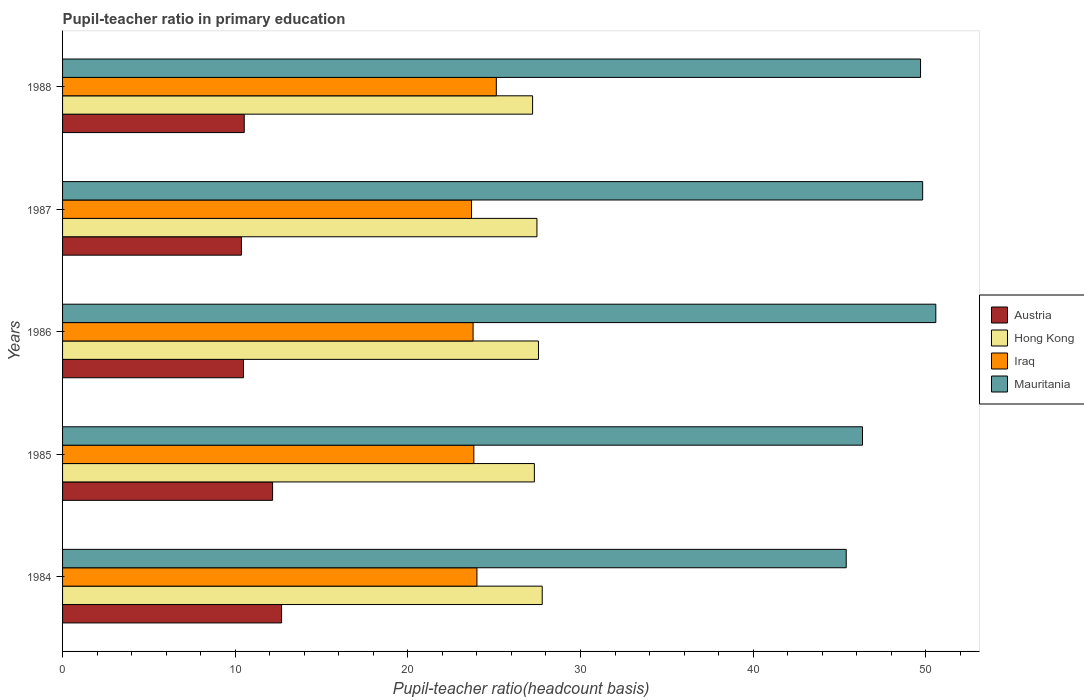In how many cases, is the number of bars for a given year not equal to the number of legend labels?
Offer a very short reply. 0. What is the pupil-teacher ratio in primary education in Iraq in 1987?
Keep it short and to the point. 23.69. Across all years, what is the maximum pupil-teacher ratio in primary education in Mauritania?
Offer a very short reply. 50.58. Across all years, what is the minimum pupil-teacher ratio in primary education in Austria?
Your answer should be very brief. 10.36. In which year was the pupil-teacher ratio in primary education in Mauritania maximum?
Offer a very short reply. 1986. What is the total pupil-teacher ratio in primary education in Hong Kong in the graph?
Give a very brief answer. 137.38. What is the difference between the pupil-teacher ratio in primary education in Iraq in 1985 and that in 1988?
Your answer should be compact. -1.3. What is the difference between the pupil-teacher ratio in primary education in Iraq in 1984 and the pupil-teacher ratio in primary education in Austria in 1986?
Your answer should be compact. 13.52. What is the average pupil-teacher ratio in primary education in Hong Kong per year?
Your response must be concise. 27.48. In the year 1984, what is the difference between the pupil-teacher ratio in primary education in Mauritania and pupil-teacher ratio in primary education in Iraq?
Your response must be concise. 21.39. In how many years, is the pupil-teacher ratio in primary education in Iraq greater than 8 ?
Your answer should be compact. 5. What is the ratio of the pupil-teacher ratio in primary education in Mauritania in 1984 to that in 1988?
Your response must be concise. 0.91. What is the difference between the highest and the second highest pupil-teacher ratio in primary education in Mauritania?
Your answer should be compact. 0.76. What is the difference between the highest and the lowest pupil-teacher ratio in primary education in Iraq?
Your answer should be compact. 1.44. Is the sum of the pupil-teacher ratio in primary education in Iraq in 1984 and 1985 greater than the maximum pupil-teacher ratio in primary education in Mauritania across all years?
Give a very brief answer. No. What does the 1st bar from the top in 1988 represents?
Keep it short and to the point. Mauritania. What does the 3rd bar from the bottom in 1988 represents?
Make the answer very short. Iraq. How many years are there in the graph?
Your answer should be compact. 5. Are the values on the major ticks of X-axis written in scientific E-notation?
Offer a very short reply. No. Does the graph contain grids?
Provide a succinct answer. No. How many legend labels are there?
Your answer should be compact. 4. What is the title of the graph?
Give a very brief answer. Pupil-teacher ratio in primary education. Does "South Africa" appear as one of the legend labels in the graph?
Make the answer very short. No. What is the label or title of the X-axis?
Ensure brevity in your answer.  Pupil-teacher ratio(headcount basis). What is the label or title of the Y-axis?
Provide a short and direct response. Years. What is the Pupil-teacher ratio(headcount basis) in Austria in 1984?
Your response must be concise. 12.69. What is the Pupil-teacher ratio(headcount basis) in Hong Kong in 1984?
Provide a short and direct response. 27.78. What is the Pupil-teacher ratio(headcount basis) of Iraq in 1984?
Provide a short and direct response. 24. What is the Pupil-teacher ratio(headcount basis) in Mauritania in 1984?
Your answer should be compact. 45.39. What is the Pupil-teacher ratio(headcount basis) of Austria in 1985?
Your answer should be compact. 12.17. What is the Pupil-teacher ratio(headcount basis) in Hong Kong in 1985?
Provide a short and direct response. 27.33. What is the Pupil-teacher ratio(headcount basis) of Iraq in 1985?
Your answer should be compact. 23.82. What is the Pupil-teacher ratio(headcount basis) of Mauritania in 1985?
Your response must be concise. 46.34. What is the Pupil-teacher ratio(headcount basis) in Austria in 1986?
Your response must be concise. 10.48. What is the Pupil-teacher ratio(headcount basis) in Hong Kong in 1986?
Make the answer very short. 27.57. What is the Pupil-teacher ratio(headcount basis) in Iraq in 1986?
Provide a short and direct response. 23.78. What is the Pupil-teacher ratio(headcount basis) of Mauritania in 1986?
Make the answer very short. 50.58. What is the Pupil-teacher ratio(headcount basis) of Austria in 1987?
Provide a short and direct response. 10.36. What is the Pupil-teacher ratio(headcount basis) in Hong Kong in 1987?
Provide a succinct answer. 27.48. What is the Pupil-teacher ratio(headcount basis) in Iraq in 1987?
Provide a succinct answer. 23.69. What is the Pupil-teacher ratio(headcount basis) in Mauritania in 1987?
Your answer should be very brief. 49.82. What is the Pupil-teacher ratio(headcount basis) in Austria in 1988?
Give a very brief answer. 10.52. What is the Pupil-teacher ratio(headcount basis) in Hong Kong in 1988?
Provide a succinct answer. 27.23. What is the Pupil-teacher ratio(headcount basis) of Iraq in 1988?
Your answer should be very brief. 25.13. What is the Pupil-teacher ratio(headcount basis) of Mauritania in 1988?
Offer a terse response. 49.7. Across all years, what is the maximum Pupil-teacher ratio(headcount basis) in Austria?
Offer a very short reply. 12.69. Across all years, what is the maximum Pupil-teacher ratio(headcount basis) in Hong Kong?
Keep it short and to the point. 27.78. Across all years, what is the maximum Pupil-teacher ratio(headcount basis) of Iraq?
Give a very brief answer. 25.13. Across all years, what is the maximum Pupil-teacher ratio(headcount basis) in Mauritania?
Make the answer very short. 50.58. Across all years, what is the minimum Pupil-teacher ratio(headcount basis) of Austria?
Make the answer very short. 10.36. Across all years, what is the minimum Pupil-teacher ratio(headcount basis) of Hong Kong?
Make the answer very short. 27.23. Across all years, what is the minimum Pupil-teacher ratio(headcount basis) in Iraq?
Your answer should be very brief. 23.69. Across all years, what is the minimum Pupil-teacher ratio(headcount basis) in Mauritania?
Offer a terse response. 45.39. What is the total Pupil-teacher ratio(headcount basis) in Austria in the graph?
Provide a succinct answer. 56.22. What is the total Pupil-teacher ratio(headcount basis) of Hong Kong in the graph?
Offer a very short reply. 137.38. What is the total Pupil-teacher ratio(headcount basis) in Iraq in the graph?
Keep it short and to the point. 120.42. What is the total Pupil-teacher ratio(headcount basis) of Mauritania in the graph?
Your response must be concise. 241.83. What is the difference between the Pupil-teacher ratio(headcount basis) in Austria in 1984 and that in 1985?
Your answer should be compact. 0.52. What is the difference between the Pupil-teacher ratio(headcount basis) in Hong Kong in 1984 and that in 1985?
Keep it short and to the point. 0.45. What is the difference between the Pupil-teacher ratio(headcount basis) of Iraq in 1984 and that in 1985?
Make the answer very short. 0.18. What is the difference between the Pupil-teacher ratio(headcount basis) in Mauritania in 1984 and that in 1985?
Provide a short and direct response. -0.94. What is the difference between the Pupil-teacher ratio(headcount basis) in Austria in 1984 and that in 1986?
Offer a terse response. 2.21. What is the difference between the Pupil-teacher ratio(headcount basis) of Hong Kong in 1984 and that in 1986?
Offer a terse response. 0.22. What is the difference between the Pupil-teacher ratio(headcount basis) of Iraq in 1984 and that in 1986?
Give a very brief answer. 0.22. What is the difference between the Pupil-teacher ratio(headcount basis) of Mauritania in 1984 and that in 1986?
Make the answer very short. -5.19. What is the difference between the Pupil-teacher ratio(headcount basis) of Austria in 1984 and that in 1987?
Offer a terse response. 2.32. What is the difference between the Pupil-teacher ratio(headcount basis) of Hong Kong in 1984 and that in 1987?
Provide a short and direct response. 0.31. What is the difference between the Pupil-teacher ratio(headcount basis) in Iraq in 1984 and that in 1987?
Your response must be concise. 0.31. What is the difference between the Pupil-teacher ratio(headcount basis) of Mauritania in 1984 and that in 1987?
Make the answer very short. -4.43. What is the difference between the Pupil-teacher ratio(headcount basis) of Austria in 1984 and that in 1988?
Make the answer very short. 2.16. What is the difference between the Pupil-teacher ratio(headcount basis) in Hong Kong in 1984 and that in 1988?
Provide a succinct answer. 0.56. What is the difference between the Pupil-teacher ratio(headcount basis) in Iraq in 1984 and that in 1988?
Provide a short and direct response. -1.12. What is the difference between the Pupil-teacher ratio(headcount basis) of Mauritania in 1984 and that in 1988?
Provide a succinct answer. -4.3. What is the difference between the Pupil-teacher ratio(headcount basis) in Austria in 1985 and that in 1986?
Your answer should be very brief. 1.69. What is the difference between the Pupil-teacher ratio(headcount basis) of Hong Kong in 1985 and that in 1986?
Offer a terse response. -0.24. What is the difference between the Pupil-teacher ratio(headcount basis) in Iraq in 1985 and that in 1986?
Your response must be concise. 0.04. What is the difference between the Pupil-teacher ratio(headcount basis) of Mauritania in 1985 and that in 1986?
Make the answer very short. -4.25. What is the difference between the Pupil-teacher ratio(headcount basis) in Austria in 1985 and that in 1987?
Your answer should be compact. 1.8. What is the difference between the Pupil-teacher ratio(headcount basis) of Hong Kong in 1985 and that in 1987?
Give a very brief answer. -0.15. What is the difference between the Pupil-teacher ratio(headcount basis) of Iraq in 1985 and that in 1987?
Make the answer very short. 0.13. What is the difference between the Pupil-teacher ratio(headcount basis) of Mauritania in 1985 and that in 1987?
Provide a short and direct response. -3.48. What is the difference between the Pupil-teacher ratio(headcount basis) in Austria in 1985 and that in 1988?
Provide a succinct answer. 1.64. What is the difference between the Pupil-teacher ratio(headcount basis) in Hong Kong in 1985 and that in 1988?
Provide a short and direct response. 0.1. What is the difference between the Pupil-teacher ratio(headcount basis) in Iraq in 1985 and that in 1988?
Keep it short and to the point. -1.3. What is the difference between the Pupil-teacher ratio(headcount basis) of Mauritania in 1985 and that in 1988?
Provide a succinct answer. -3.36. What is the difference between the Pupil-teacher ratio(headcount basis) in Austria in 1986 and that in 1987?
Give a very brief answer. 0.12. What is the difference between the Pupil-teacher ratio(headcount basis) in Hong Kong in 1986 and that in 1987?
Your answer should be compact. 0.09. What is the difference between the Pupil-teacher ratio(headcount basis) of Iraq in 1986 and that in 1987?
Give a very brief answer. 0.09. What is the difference between the Pupil-teacher ratio(headcount basis) in Mauritania in 1986 and that in 1987?
Your answer should be very brief. 0.76. What is the difference between the Pupil-teacher ratio(headcount basis) in Austria in 1986 and that in 1988?
Offer a very short reply. -0.04. What is the difference between the Pupil-teacher ratio(headcount basis) in Hong Kong in 1986 and that in 1988?
Ensure brevity in your answer.  0.34. What is the difference between the Pupil-teacher ratio(headcount basis) in Iraq in 1986 and that in 1988?
Your answer should be very brief. -1.35. What is the difference between the Pupil-teacher ratio(headcount basis) in Mauritania in 1986 and that in 1988?
Give a very brief answer. 0.89. What is the difference between the Pupil-teacher ratio(headcount basis) in Austria in 1987 and that in 1988?
Offer a very short reply. -0.16. What is the difference between the Pupil-teacher ratio(headcount basis) of Hong Kong in 1987 and that in 1988?
Offer a terse response. 0.25. What is the difference between the Pupil-teacher ratio(headcount basis) of Iraq in 1987 and that in 1988?
Provide a succinct answer. -1.44. What is the difference between the Pupil-teacher ratio(headcount basis) of Mauritania in 1987 and that in 1988?
Keep it short and to the point. 0.12. What is the difference between the Pupil-teacher ratio(headcount basis) of Austria in 1984 and the Pupil-teacher ratio(headcount basis) of Hong Kong in 1985?
Make the answer very short. -14.64. What is the difference between the Pupil-teacher ratio(headcount basis) of Austria in 1984 and the Pupil-teacher ratio(headcount basis) of Iraq in 1985?
Your answer should be compact. -11.14. What is the difference between the Pupil-teacher ratio(headcount basis) in Austria in 1984 and the Pupil-teacher ratio(headcount basis) in Mauritania in 1985?
Make the answer very short. -33.65. What is the difference between the Pupil-teacher ratio(headcount basis) of Hong Kong in 1984 and the Pupil-teacher ratio(headcount basis) of Iraq in 1985?
Ensure brevity in your answer.  3.96. What is the difference between the Pupil-teacher ratio(headcount basis) of Hong Kong in 1984 and the Pupil-teacher ratio(headcount basis) of Mauritania in 1985?
Your answer should be very brief. -18.55. What is the difference between the Pupil-teacher ratio(headcount basis) of Iraq in 1984 and the Pupil-teacher ratio(headcount basis) of Mauritania in 1985?
Provide a short and direct response. -22.33. What is the difference between the Pupil-teacher ratio(headcount basis) of Austria in 1984 and the Pupil-teacher ratio(headcount basis) of Hong Kong in 1986?
Your response must be concise. -14.88. What is the difference between the Pupil-teacher ratio(headcount basis) in Austria in 1984 and the Pupil-teacher ratio(headcount basis) in Iraq in 1986?
Keep it short and to the point. -11.09. What is the difference between the Pupil-teacher ratio(headcount basis) in Austria in 1984 and the Pupil-teacher ratio(headcount basis) in Mauritania in 1986?
Offer a terse response. -37.9. What is the difference between the Pupil-teacher ratio(headcount basis) in Hong Kong in 1984 and the Pupil-teacher ratio(headcount basis) in Iraq in 1986?
Offer a very short reply. 4.01. What is the difference between the Pupil-teacher ratio(headcount basis) of Hong Kong in 1984 and the Pupil-teacher ratio(headcount basis) of Mauritania in 1986?
Offer a terse response. -22.8. What is the difference between the Pupil-teacher ratio(headcount basis) of Iraq in 1984 and the Pupil-teacher ratio(headcount basis) of Mauritania in 1986?
Make the answer very short. -26.58. What is the difference between the Pupil-teacher ratio(headcount basis) of Austria in 1984 and the Pupil-teacher ratio(headcount basis) of Hong Kong in 1987?
Your answer should be very brief. -14.79. What is the difference between the Pupil-teacher ratio(headcount basis) in Austria in 1984 and the Pupil-teacher ratio(headcount basis) in Iraq in 1987?
Your answer should be compact. -11. What is the difference between the Pupil-teacher ratio(headcount basis) in Austria in 1984 and the Pupil-teacher ratio(headcount basis) in Mauritania in 1987?
Offer a very short reply. -37.13. What is the difference between the Pupil-teacher ratio(headcount basis) in Hong Kong in 1984 and the Pupil-teacher ratio(headcount basis) in Iraq in 1987?
Your answer should be compact. 4.1. What is the difference between the Pupil-teacher ratio(headcount basis) of Hong Kong in 1984 and the Pupil-teacher ratio(headcount basis) of Mauritania in 1987?
Provide a short and direct response. -22.04. What is the difference between the Pupil-teacher ratio(headcount basis) of Iraq in 1984 and the Pupil-teacher ratio(headcount basis) of Mauritania in 1987?
Give a very brief answer. -25.82. What is the difference between the Pupil-teacher ratio(headcount basis) in Austria in 1984 and the Pupil-teacher ratio(headcount basis) in Hong Kong in 1988?
Make the answer very short. -14.54. What is the difference between the Pupil-teacher ratio(headcount basis) of Austria in 1984 and the Pupil-teacher ratio(headcount basis) of Iraq in 1988?
Your answer should be very brief. -12.44. What is the difference between the Pupil-teacher ratio(headcount basis) of Austria in 1984 and the Pupil-teacher ratio(headcount basis) of Mauritania in 1988?
Ensure brevity in your answer.  -37.01. What is the difference between the Pupil-teacher ratio(headcount basis) in Hong Kong in 1984 and the Pupil-teacher ratio(headcount basis) in Iraq in 1988?
Give a very brief answer. 2.66. What is the difference between the Pupil-teacher ratio(headcount basis) of Hong Kong in 1984 and the Pupil-teacher ratio(headcount basis) of Mauritania in 1988?
Your answer should be compact. -21.91. What is the difference between the Pupil-teacher ratio(headcount basis) in Iraq in 1984 and the Pupil-teacher ratio(headcount basis) in Mauritania in 1988?
Make the answer very short. -25.69. What is the difference between the Pupil-teacher ratio(headcount basis) in Austria in 1985 and the Pupil-teacher ratio(headcount basis) in Hong Kong in 1986?
Your response must be concise. -15.4. What is the difference between the Pupil-teacher ratio(headcount basis) in Austria in 1985 and the Pupil-teacher ratio(headcount basis) in Iraq in 1986?
Offer a very short reply. -11.61. What is the difference between the Pupil-teacher ratio(headcount basis) in Austria in 1985 and the Pupil-teacher ratio(headcount basis) in Mauritania in 1986?
Give a very brief answer. -38.42. What is the difference between the Pupil-teacher ratio(headcount basis) of Hong Kong in 1985 and the Pupil-teacher ratio(headcount basis) of Iraq in 1986?
Ensure brevity in your answer.  3.55. What is the difference between the Pupil-teacher ratio(headcount basis) of Hong Kong in 1985 and the Pupil-teacher ratio(headcount basis) of Mauritania in 1986?
Your answer should be compact. -23.25. What is the difference between the Pupil-teacher ratio(headcount basis) in Iraq in 1985 and the Pupil-teacher ratio(headcount basis) in Mauritania in 1986?
Make the answer very short. -26.76. What is the difference between the Pupil-teacher ratio(headcount basis) in Austria in 1985 and the Pupil-teacher ratio(headcount basis) in Hong Kong in 1987?
Offer a terse response. -15.31. What is the difference between the Pupil-teacher ratio(headcount basis) of Austria in 1985 and the Pupil-teacher ratio(headcount basis) of Iraq in 1987?
Keep it short and to the point. -11.52. What is the difference between the Pupil-teacher ratio(headcount basis) of Austria in 1985 and the Pupil-teacher ratio(headcount basis) of Mauritania in 1987?
Keep it short and to the point. -37.65. What is the difference between the Pupil-teacher ratio(headcount basis) in Hong Kong in 1985 and the Pupil-teacher ratio(headcount basis) in Iraq in 1987?
Provide a succinct answer. 3.64. What is the difference between the Pupil-teacher ratio(headcount basis) of Hong Kong in 1985 and the Pupil-teacher ratio(headcount basis) of Mauritania in 1987?
Your answer should be compact. -22.49. What is the difference between the Pupil-teacher ratio(headcount basis) in Iraq in 1985 and the Pupil-teacher ratio(headcount basis) in Mauritania in 1987?
Provide a short and direct response. -26. What is the difference between the Pupil-teacher ratio(headcount basis) of Austria in 1985 and the Pupil-teacher ratio(headcount basis) of Hong Kong in 1988?
Offer a very short reply. -15.06. What is the difference between the Pupil-teacher ratio(headcount basis) of Austria in 1985 and the Pupil-teacher ratio(headcount basis) of Iraq in 1988?
Give a very brief answer. -12.96. What is the difference between the Pupil-teacher ratio(headcount basis) in Austria in 1985 and the Pupil-teacher ratio(headcount basis) in Mauritania in 1988?
Offer a terse response. -37.53. What is the difference between the Pupil-teacher ratio(headcount basis) in Hong Kong in 1985 and the Pupil-teacher ratio(headcount basis) in Iraq in 1988?
Keep it short and to the point. 2.2. What is the difference between the Pupil-teacher ratio(headcount basis) in Hong Kong in 1985 and the Pupil-teacher ratio(headcount basis) in Mauritania in 1988?
Offer a terse response. -22.37. What is the difference between the Pupil-teacher ratio(headcount basis) of Iraq in 1985 and the Pupil-teacher ratio(headcount basis) of Mauritania in 1988?
Keep it short and to the point. -25.87. What is the difference between the Pupil-teacher ratio(headcount basis) in Austria in 1986 and the Pupil-teacher ratio(headcount basis) in Hong Kong in 1987?
Your answer should be very brief. -17. What is the difference between the Pupil-teacher ratio(headcount basis) in Austria in 1986 and the Pupil-teacher ratio(headcount basis) in Iraq in 1987?
Your response must be concise. -13.21. What is the difference between the Pupil-teacher ratio(headcount basis) of Austria in 1986 and the Pupil-teacher ratio(headcount basis) of Mauritania in 1987?
Your answer should be very brief. -39.34. What is the difference between the Pupil-teacher ratio(headcount basis) of Hong Kong in 1986 and the Pupil-teacher ratio(headcount basis) of Iraq in 1987?
Ensure brevity in your answer.  3.88. What is the difference between the Pupil-teacher ratio(headcount basis) of Hong Kong in 1986 and the Pupil-teacher ratio(headcount basis) of Mauritania in 1987?
Offer a very short reply. -22.25. What is the difference between the Pupil-teacher ratio(headcount basis) of Iraq in 1986 and the Pupil-teacher ratio(headcount basis) of Mauritania in 1987?
Your answer should be compact. -26.04. What is the difference between the Pupil-teacher ratio(headcount basis) of Austria in 1986 and the Pupil-teacher ratio(headcount basis) of Hong Kong in 1988?
Keep it short and to the point. -16.75. What is the difference between the Pupil-teacher ratio(headcount basis) of Austria in 1986 and the Pupil-teacher ratio(headcount basis) of Iraq in 1988?
Offer a very short reply. -14.64. What is the difference between the Pupil-teacher ratio(headcount basis) in Austria in 1986 and the Pupil-teacher ratio(headcount basis) in Mauritania in 1988?
Offer a terse response. -39.22. What is the difference between the Pupil-teacher ratio(headcount basis) in Hong Kong in 1986 and the Pupil-teacher ratio(headcount basis) in Iraq in 1988?
Provide a short and direct response. 2.44. What is the difference between the Pupil-teacher ratio(headcount basis) in Hong Kong in 1986 and the Pupil-teacher ratio(headcount basis) in Mauritania in 1988?
Your answer should be compact. -22.13. What is the difference between the Pupil-teacher ratio(headcount basis) of Iraq in 1986 and the Pupil-teacher ratio(headcount basis) of Mauritania in 1988?
Your answer should be very brief. -25.92. What is the difference between the Pupil-teacher ratio(headcount basis) of Austria in 1987 and the Pupil-teacher ratio(headcount basis) of Hong Kong in 1988?
Offer a very short reply. -16.86. What is the difference between the Pupil-teacher ratio(headcount basis) of Austria in 1987 and the Pupil-teacher ratio(headcount basis) of Iraq in 1988?
Give a very brief answer. -14.76. What is the difference between the Pupil-teacher ratio(headcount basis) of Austria in 1987 and the Pupil-teacher ratio(headcount basis) of Mauritania in 1988?
Ensure brevity in your answer.  -39.33. What is the difference between the Pupil-teacher ratio(headcount basis) of Hong Kong in 1987 and the Pupil-teacher ratio(headcount basis) of Iraq in 1988?
Make the answer very short. 2.35. What is the difference between the Pupil-teacher ratio(headcount basis) of Hong Kong in 1987 and the Pupil-teacher ratio(headcount basis) of Mauritania in 1988?
Your answer should be very brief. -22.22. What is the difference between the Pupil-teacher ratio(headcount basis) of Iraq in 1987 and the Pupil-teacher ratio(headcount basis) of Mauritania in 1988?
Ensure brevity in your answer.  -26.01. What is the average Pupil-teacher ratio(headcount basis) in Austria per year?
Provide a short and direct response. 11.24. What is the average Pupil-teacher ratio(headcount basis) in Hong Kong per year?
Your answer should be compact. 27.48. What is the average Pupil-teacher ratio(headcount basis) of Iraq per year?
Offer a very short reply. 24.08. What is the average Pupil-teacher ratio(headcount basis) in Mauritania per year?
Provide a short and direct response. 48.37. In the year 1984, what is the difference between the Pupil-teacher ratio(headcount basis) in Austria and Pupil-teacher ratio(headcount basis) in Hong Kong?
Make the answer very short. -15.1. In the year 1984, what is the difference between the Pupil-teacher ratio(headcount basis) in Austria and Pupil-teacher ratio(headcount basis) in Iraq?
Your answer should be very brief. -11.32. In the year 1984, what is the difference between the Pupil-teacher ratio(headcount basis) of Austria and Pupil-teacher ratio(headcount basis) of Mauritania?
Give a very brief answer. -32.71. In the year 1984, what is the difference between the Pupil-teacher ratio(headcount basis) in Hong Kong and Pupil-teacher ratio(headcount basis) in Iraq?
Ensure brevity in your answer.  3.78. In the year 1984, what is the difference between the Pupil-teacher ratio(headcount basis) of Hong Kong and Pupil-teacher ratio(headcount basis) of Mauritania?
Your answer should be very brief. -17.61. In the year 1984, what is the difference between the Pupil-teacher ratio(headcount basis) in Iraq and Pupil-teacher ratio(headcount basis) in Mauritania?
Keep it short and to the point. -21.39. In the year 1985, what is the difference between the Pupil-teacher ratio(headcount basis) of Austria and Pupil-teacher ratio(headcount basis) of Hong Kong?
Your response must be concise. -15.16. In the year 1985, what is the difference between the Pupil-teacher ratio(headcount basis) in Austria and Pupil-teacher ratio(headcount basis) in Iraq?
Give a very brief answer. -11.66. In the year 1985, what is the difference between the Pupil-teacher ratio(headcount basis) in Austria and Pupil-teacher ratio(headcount basis) in Mauritania?
Your answer should be very brief. -34.17. In the year 1985, what is the difference between the Pupil-teacher ratio(headcount basis) of Hong Kong and Pupil-teacher ratio(headcount basis) of Iraq?
Provide a succinct answer. 3.51. In the year 1985, what is the difference between the Pupil-teacher ratio(headcount basis) in Hong Kong and Pupil-teacher ratio(headcount basis) in Mauritania?
Ensure brevity in your answer.  -19.01. In the year 1985, what is the difference between the Pupil-teacher ratio(headcount basis) of Iraq and Pupil-teacher ratio(headcount basis) of Mauritania?
Provide a short and direct response. -22.51. In the year 1986, what is the difference between the Pupil-teacher ratio(headcount basis) of Austria and Pupil-teacher ratio(headcount basis) of Hong Kong?
Your answer should be very brief. -17.09. In the year 1986, what is the difference between the Pupil-teacher ratio(headcount basis) of Austria and Pupil-teacher ratio(headcount basis) of Iraq?
Provide a succinct answer. -13.3. In the year 1986, what is the difference between the Pupil-teacher ratio(headcount basis) of Austria and Pupil-teacher ratio(headcount basis) of Mauritania?
Your response must be concise. -40.1. In the year 1986, what is the difference between the Pupil-teacher ratio(headcount basis) in Hong Kong and Pupil-teacher ratio(headcount basis) in Iraq?
Offer a very short reply. 3.79. In the year 1986, what is the difference between the Pupil-teacher ratio(headcount basis) in Hong Kong and Pupil-teacher ratio(headcount basis) in Mauritania?
Offer a very short reply. -23.02. In the year 1986, what is the difference between the Pupil-teacher ratio(headcount basis) of Iraq and Pupil-teacher ratio(headcount basis) of Mauritania?
Your response must be concise. -26.8. In the year 1987, what is the difference between the Pupil-teacher ratio(headcount basis) in Austria and Pupil-teacher ratio(headcount basis) in Hong Kong?
Keep it short and to the point. -17.11. In the year 1987, what is the difference between the Pupil-teacher ratio(headcount basis) in Austria and Pupil-teacher ratio(headcount basis) in Iraq?
Offer a very short reply. -13.32. In the year 1987, what is the difference between the Pupil-teacher ratio(headcount basis) in Austria and Pupil-teacher ratio(headcount basis) in Mauritania?
Provide a succinct answer. -39.46. In the year 1987, what is the difference between the Pupil-teacher ratio(headcount basis) of Hong Kong and Pupil-teacher ratio(headcount basis) of Iraq?
Offer a terse response. 3.79. In the year 1987, what is the difference between the Pupil-teacher ratio(headcount basis) of Hong Kong and Pupil-teacher ratio(headcount basis) of Mauritania?
Offer a terse response. -22.34. In the year 1987, what is the difference between the Pupil-teacher ratio(headcount basis) of Iraq and Pupil-teacher ratio(headcount basis) of Mauritania?
Offer a very short reply. -26.13. In the year 1988, what is the difference between the Pupil-teacher ratio(headcount basis) of Austria and Pupil-teacher ratio(headcount basis) of Hong Kong?
Make the answer very short. -16.7. In the year 1988, what is the difference between the Pupil-teacher ratio(headcount basis) in Austria and Pupil-teacher ratio(headcount basis) in Iraq?
Offer a terse response. -14.6. In the year 1988, what is the difference between the Pupil-teacher ratio(headcount basis) of Austria and Pupil-teacher ratio(headcount basis) of Mauritania?
Your answer should be compact. -39.17. In the year 1988, what is the difference between the Pupil-teacher ratio(headcount basis) of Hong Kong and Pupil-teacher ratio(headcount basis) of Iraq?
Give a very brief answer. 2.1. In the year 1988, what is the difference between the Pupil-teacher ratio(headcount basis) of Hong Kong and Pupil-teacher ratio(headcount basis) of Mauritania?
Provide a succinct answer. -22.47. In the year 1988, what is the difference between the Pupil-teacher ratio(headcount basis) in Iraq and Pupil-teacher ratio(headcount basis) in Mauritania?
Give a very brief answer. -24.57. What is the ratio of the Pupil-teacher ratio(headcount basis) of Austria in 1984 to that in 1985?
Your answer should be very brief. 1.04. What is the ratio of the Pupil-teacher ratio(headcount basis) in Hong Kong in 1984 to that in 1985?
Offer a very short reply. 1.02. What is the ratio of the Pupil-teacher ratio(headcount basis) in Iraq in 1984 to that in 1985?
Make the answer very short. 1.01. What is the ratio of the Pupil-teacher ratio(headcount basis) in Mauritania in 1984 to that in 1985?
Provide a short and direct response. 0.98. What is the ratio of the Pupil-teacher ratio(headcount basis) in Austria in 1984 to that in 1986?
Your response must be concise. 1.21. What is the ratio of the Pupil-teacher ratio(headcount basis) of Hong Kong in 1984 to that in 1986?
Provide a succinct answer. 1.01. What is the ratio of the Pupil-teacher ratio(headcount basis) of Iraq in 1984 to that in 1986?
Your answer should be compact. 1.01. What is the ratio of the Pupil-teacher ratio(headcount basis) in Mauritania in 1984 to that in 1986?
Offer a terse response. 0.9. What is the ratio of the Pupil-teacher ratio(headcount basis) in Austria in 1984 to that in 1987?
Provide a succinct answer. 1.22. What is the ratio of the Pupil-teacher ratio(headcount basis) of Hong Kong in 1984 to that in 1987?
Make the answer very short. 1.01. What is the ratio of the Pupil-teacher ratio(headcount basis) of Iraq in 1984 to that in 1987?
Offer a very short reply. 1.01. What is the ratio of the Pupil-teacher ratio(headcount basis) of Mauritania in 1984 to that in 1987?
Provide a succinct answer. 0.91. What is the ratio of the Pupil-teacher ratio(headcount basis) of Austria in 1984 to that in 1988?
Give a very brief answer. 1.21. What is the ratio of the Pupil-teacher ratio(headcount basis) of Hong Kong in 1984 to that in 1988?
Offer a terse response. 1.02. What is the ratio of the Pupil-teacher ratio(headcount basis) of Iraq in 1984 to that in 1988?
Your answer should be very brief. 0.96. What is the ratio of the Pupil-teacher ratio(headcount basis) of Mauritania in 1984 to that in 1988?
Provide a short and direct response. 0.91. What is the ratio of the Pupil-teacher ratio(headcount basis) in Austria in 1985 to that in 1986?
Provide a short and direct response. 1.16. What is the ratio of the Pupil-teacher ratio(headcount basis) in Mauritania in 1985 to that in 1986?
Your answer should be very brief. 0.92. What is the ratio of the Pupil-teacher ratio(headcount basis) in Austria in 1985 to that in 1987?
Provide a succinct answer. 1.17. What is the ratio of the Pupil-teacher ratio(headcount basis) of Iraq in 1985 to that in 1987?
Ensure brevity in your answer.  1.01. What is the ratio of the Pupil-teacher ratio(headcount basis) in Mauritania in 1985 to that in 1987?
Offer a very short reply. 0.93. What is the ratio of the Pupil-teacher ratio(headcount basis) of Austria in 1985 to that in 1988?
Provide a short and direct response. 1.16. What is the ratio of the Pupil-teacher ratio(headcount basis) in Hong Kong in 1985 to that in 1988?
Offer a very short reply. 1. What is the ratio of the Pupil-teacher ratio(headcount basis) in Iraq in 1985 to that in 1988?
Your response must be concise. 0.95. What is the ratio of the Pupil-teacher ratio(headcount basis) in Mauritania in 1985 to that in 1988?
Keep it short and to the point. 0.93. What is the ratio of the Pupil-teacher ratio(headcount basis) of Austria in 1986 to that in 1987?
Provide a succinct answer. 1.01. What is the ratio of the Pupil-teacher ratio(headcount basis) of Mauritania in 1986 to that in 1987?
Offer a very short reply. 1.02. What is the ratio of the Pupil-teacher ratio(headcount basis) in Austria in 1986 to that in 1988?
Make the answer very short. 1. What is the ratio of the Pupil-teacher ratio(headcount basis) of Hong Kong in 1986 to that in 1988?
Provide a short and direct response. 1.01. What is the ratio of the Pupil-teacher ratio(headcount basis) of Iraq in 1986 to that in 1988?
Ensure brevity in your answer.  0.95. What is the ratio of the Pupil-teacher ratio(headcount basis) in Mauritania in 1986 to that in 1988?
Your answer should be compact. 1.02. What is the ratio of the Pupil-teacher ratio(headcount basis) of Austria in 1987 to that in 1988?
Your response must be concise. 0.98. What is the ratio of the Pupil-teacher ratio(headcount basis) of Hong Kong in 1987 to that in 1988?
Provide a short and direct response. 1.01. What is the ratio of the Pupil-teacher ratio(headcount basis) of Iraq in 1987 to that in 1988?
Your response must be concise. 0.94. What is the ratio of the Pupil-teacher ratio(headcount basis) of Mauritania in 1987 to that in 1988?
Your answer should be very brief. 1. What is the difference between the highest and the second highest Pupil-teacher ratio(headcount basis) of Austria?
Ensure brevity in your answer.  0.52. What is the difference between the highest and the second highest Pupil-teacher ratio(headcount basis) of Hong Kong?
Ensure brevity in your answer.  0.22. What is the difference between the highest and the second highest Pupil-teacher ratio(headcount basis) of Iraq?
Give a very brief answer. 1.12. What is the difference between the highest and the second highest Pupil-teacher ratio(headcount basis) in Mauritania?
Your answer should be very brief. 0.76. What is the difference between the highest and the lowest Pupil-teacher ratio(headcount basis) of Austria?
Ensure brevity in your answer.  2.32. What is the difference between the highest and the lowest Pupil-teacher ratio(headcount basis) in Hong Kong?
Make the answer very short. 0.56. What is the difference between the highest and the lowest Pupil-teacher ratio(headcount basis) of Iraq?
Provide a short and direct response. 1.44. What is the difference between the highest and the lowest Pupil-teacher ratio(headcount basis) of Mauritania?
Your response must be concise. 5.19. 